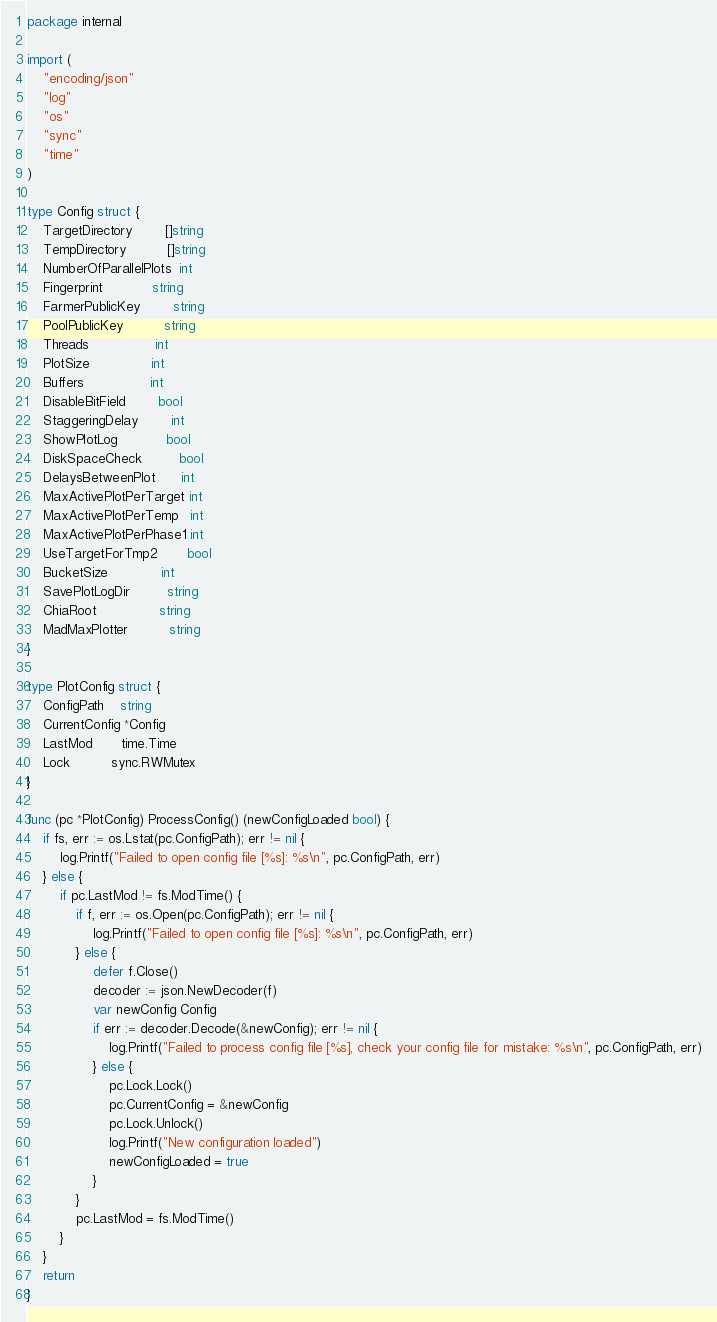Convert code to text. <code><loc_0><loc_0><loc_500><loc_500><_Go_>package internal

import (
	"encoding/json"
	"log"
	"os"
	"sync"
	"time"
)

type Config struct {
	TargetDirectory        []string
	TempDirectory          []string
	NumberOfParallelPlots  int
	Fingerprint            string
	FarmerPublicKey        string
	PoolPublicKey          string
	Threads                int
	PlotSize               int
	Buffers                int
	DisableBitField        bool
	StaggeringDelay        int
	ShowPlotLog            bool
	DiskSpaceCheck         bool
	DelaysBetweenPlot      int
	MaxActivePlotPerTarget int
	MaxActivePlotPerTemp   int
	MaxActivePlotPerPhase1 int
	UseTargetForTmp2       bool
	BucketSize             int
	SavePlotLogDir         string
	ChiaRoot               string
	MadMaxPlotter          string
}

type PlotConfig struct {
	ConfigPath    string
	CurrentConfig *Config
	LastMod       time.Time
	Lock          sync.RWMutex
}

func (pc *PlotConfig) ProcessConfig() (newConfigLoaded bool) {
	if fs, err := os.Lstat(pc.ConfigPath); err != nil {
		log.Printf("Failed to open config file [%s]: %s\n", pc.ConfigPath, err)
	} else {
		if pc.LastMod != fs.ModTime() {
			if f, err := os.Open(pc.ConfigPath); err != nil {
				log.Printf("Failed to open config file [%s]: %s\n", pc.ConfigPath, err)
			} else {
				defer f.Close()
				decoder := json.NewDecoder(f)
				var newConfig Config
				if err := decoder.Decode(&newConfig); err != nil {
					log.Printf("Failed to process config file [%s], check your config file for mistake: %s\n", pc.ConfigPath, err)
				} else {
					pc.Lock.Lock()
					pc.CurrentConfig = &newConfig
					pc.Lock.Unlock()
					log.Printf("New configuration loaded")
					newConfigLoaded = true
				}
			}
			pc.LastMod = fs.ModTime()
		}
	}
	return
}
</code> 